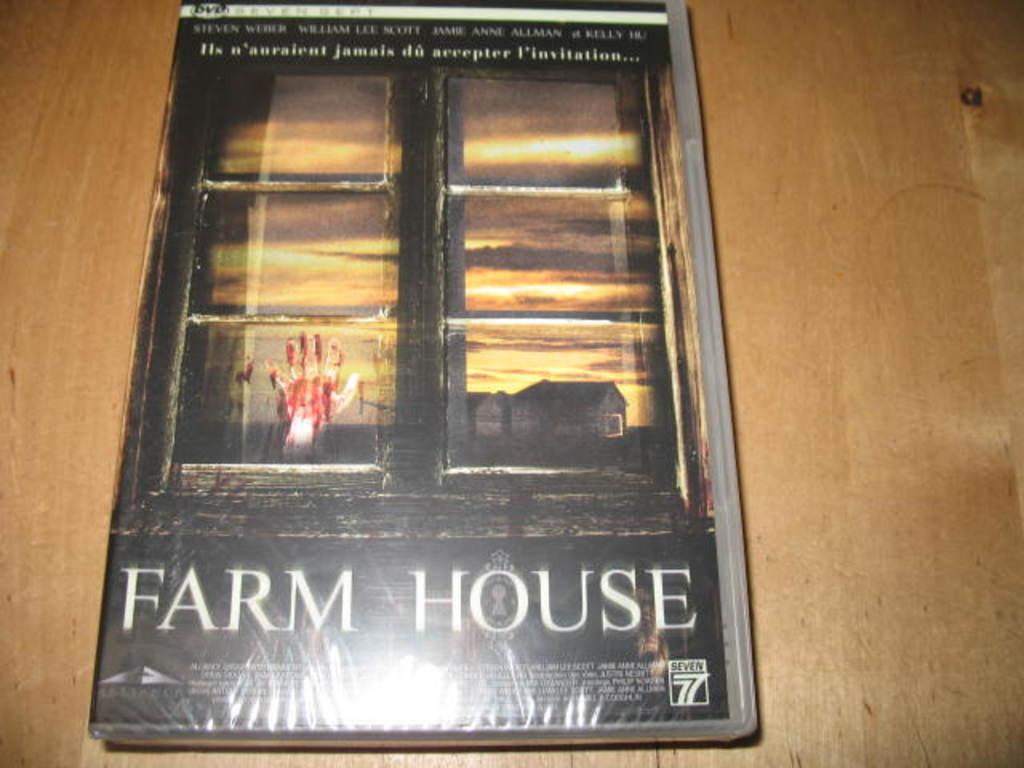<image>
Relay a brief, clear account of the picture shown. A movie case with the movie titled Farm House. 